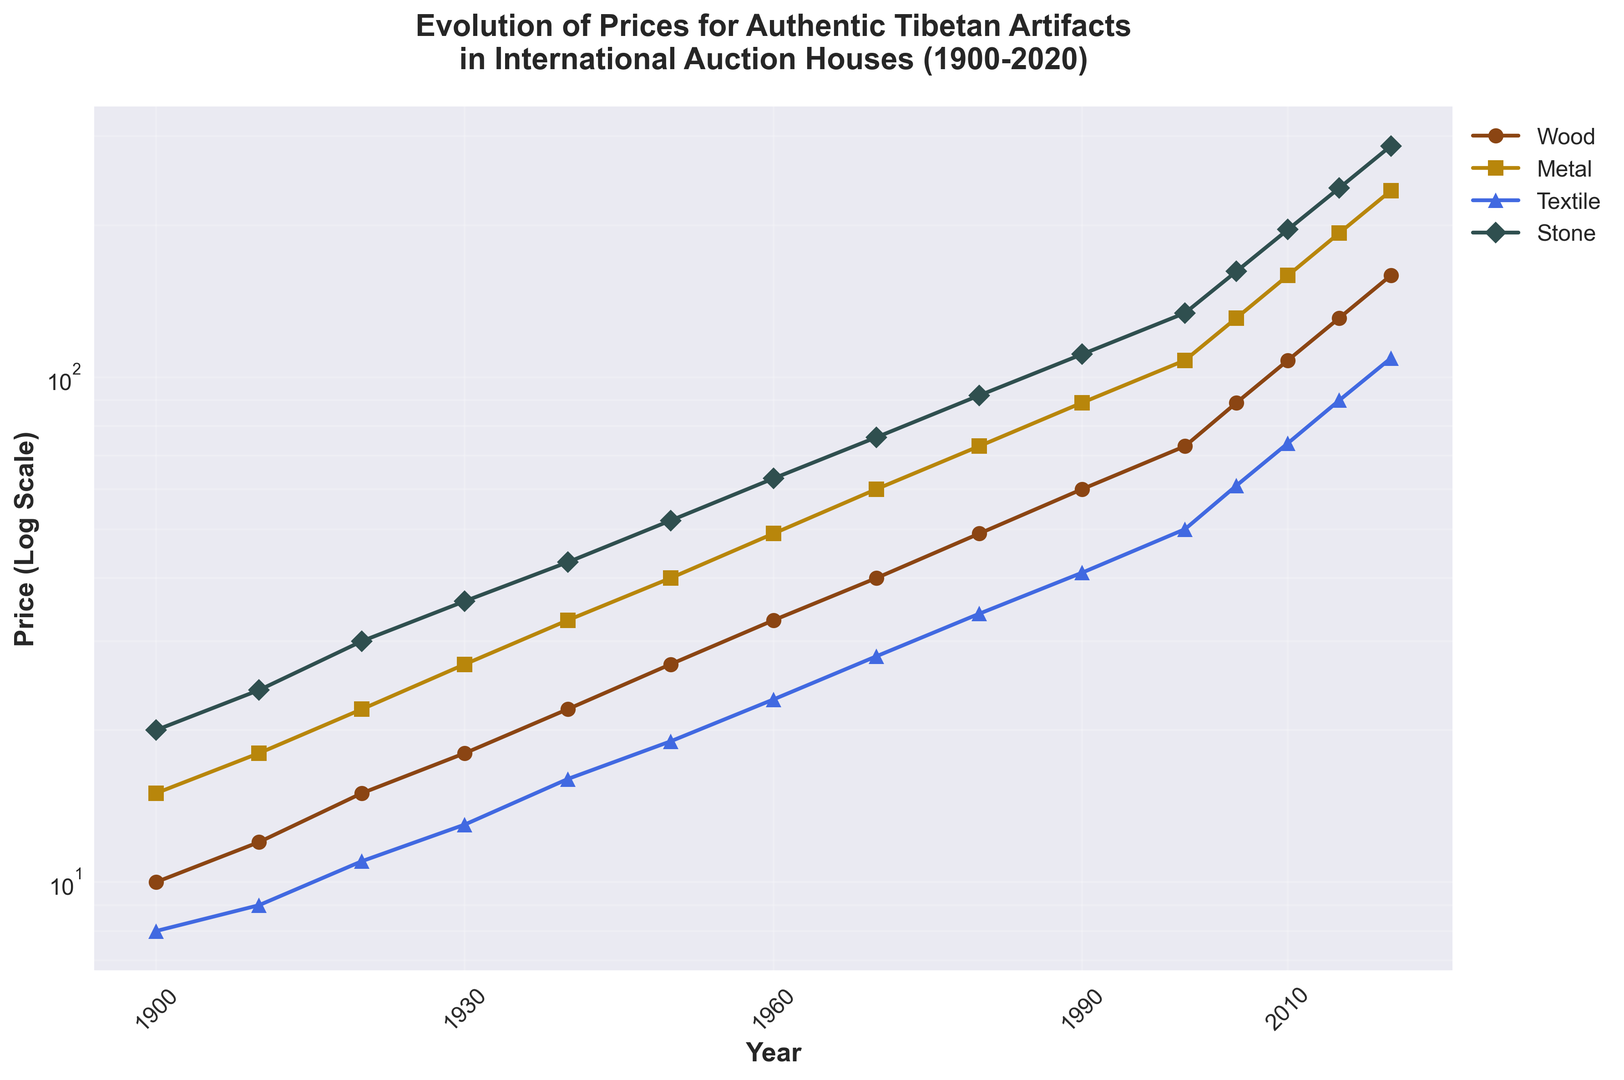Which type of Tibetan artifact had the highest increase in price from 1900 to 2020? To determine the highest increase in price from 1900 to 2020, subtract the starting price in 1900 from the ending price in 2020 for each material (Wood, Metal, Textile, and Stone). For Wood: 159 - 10 = 149. For Metal: 234 - 15 = 219. For Textile: 109 - 8 = 101. For Stone: 287 - 20 = 267. Stone had the highest increase in price.
Answer: Stone How did the prices of Tibetan artifacts made of wood compare to those made of textile in 2005? Look at the plotted values for Wood and Textile in 2005. The price for Wood is 89, while the price for Textile is 61. Wood artifacts were more expensive than Textile artifacts in 2005.
Answer: Wood artifacts were more expensive What is the approximate trend of price changes for metal artifacts from 1960 to 1980? Observe the trend for Metal from 1960 to 1980 by noting the prices at those years. In 1960: 49, in 1970: 60, and in 1980: 73. The prices gradually increase over this period.
Answer: Gradual increase Which material shows the most consistent upward trend in prices over the period from 1900 to 2020? By observing the chart, each material shows an upward trend but Stone consistently increases without any drop or stagnation points.
Answer: Stone Between which two consecutive decades did textile artifacts experience the greatest relative increase in price? By observing the values for Textile artifacts, we compare the ratios of price increases between each decade. Notably, from 2000 (50) to 2010 (74), ratio = 74/50 = 1.48. This is greater than other decades.
Answer: 2000 to 2010 What year did metal artifacts' prices exceed 100 for the first time? Observe the point where Metal prices first cross 100. In 2000, the price for Metal is 108, which is the first instance it exceeds 100.
Answer: 2000 How does the price of stone artifacts in 2015 compare to the price of metal artifacts in 1990? Look at the values for Stone in 2015 (237) and Metal in 1990 (89). Stone in 2015 is significantly higher than Metal in 1990.
Answer: Stone artifacts in 2015 were more expensive By what factor did the price of wood artifacts increase from 1900 to 2015? Divide the price in 2015 by the price in 1900 for Wood: 131 / 10 = 13.1. The price of Wood artifacts increased by a factor of 13.1.
Answer: 13.1 Which material had the largest price relative to others in 1980? Note the prices for all materials in 1980: Wood (49), Metal (73), Textile (34), Stone (92). Stone had the largest price relative to others.
Answer: Stone 